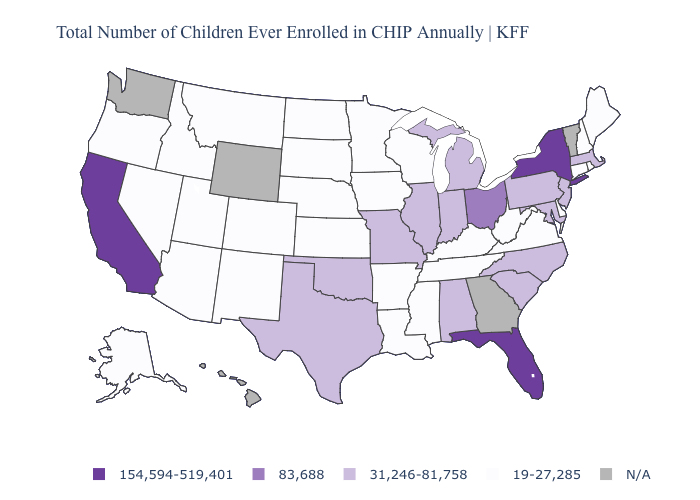What is the highest value in the USA?
Short answer required. 154,594-519,401. What is the highest value in the South ?
Give a very brief answer. 154,594-519,401. Name the states that have a value in the range 19-27,285?
Short answer required. Alaska, Arizona, Arkansas, Colorado, Connecticut, Delaware, Idaho, Iowa, Kansas, Kentucky, Louisiana, Maine, Minnesota, Mississippi, Montana, Nebraska, Nevada, New Hampshire, New Mexico, North Dakota, Oregon, Rhode Island, South Dakota, Tennessee, Utah, Virginia, West Virginia, Wisconsin. Which states have the highest value in the USA?
Short answer required. California, Florida, New York. What is the lowest value in the USA?
Answer briefly. 19-27,285. What is the highest value in the USA?
Give a very brief answer. 154,594-519,401. What is the value of Arizona?
Concise answer only. 19-27,285. Among the states that border Oregon , does Nevada have the lowest value?
Answer briefly. Yes. Does Colorado have the highest value in the USA?
Concise answer only. No. Among the states that border California , which have the lowest value?
Give a very brief answer. Arizona, Nevada, Oregon. What is the highest value in the USA?
Quick response, please. 154,594-519,401. Does the first symbol in the legend represent the smallest category?
Answer briefly. No. Does Wisconsin have the lowest value in the USA?
Give a very brief answer. Yes. 